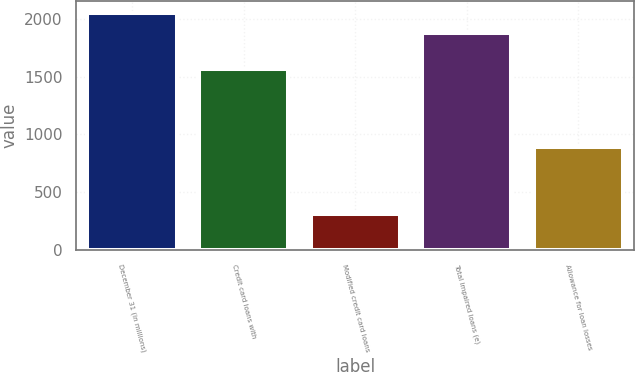Convert chart to OTSL. <chart><loc_0><loc_0><loc_500><loc_500><bar_chart><fcel>December 31 (in millions)<fcel>Credit card loans with<fcel>Modified credit card loans<fcel>Total impaired loans (e)<fcel>Allowance for loan losses<nl><fcel>2050.9<fcel>1570<fcel>311<fcel>1881<fcel>894<nl></chart> 